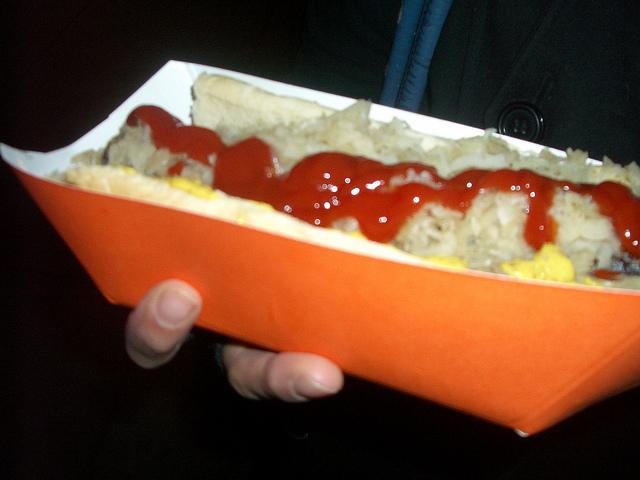What is the main topping?
Quick response, please. Ketchup. How many of the person's fingers are visible?
Quick response, please. 2. What is in the picture?
Write a very short answer. Hot dog. 